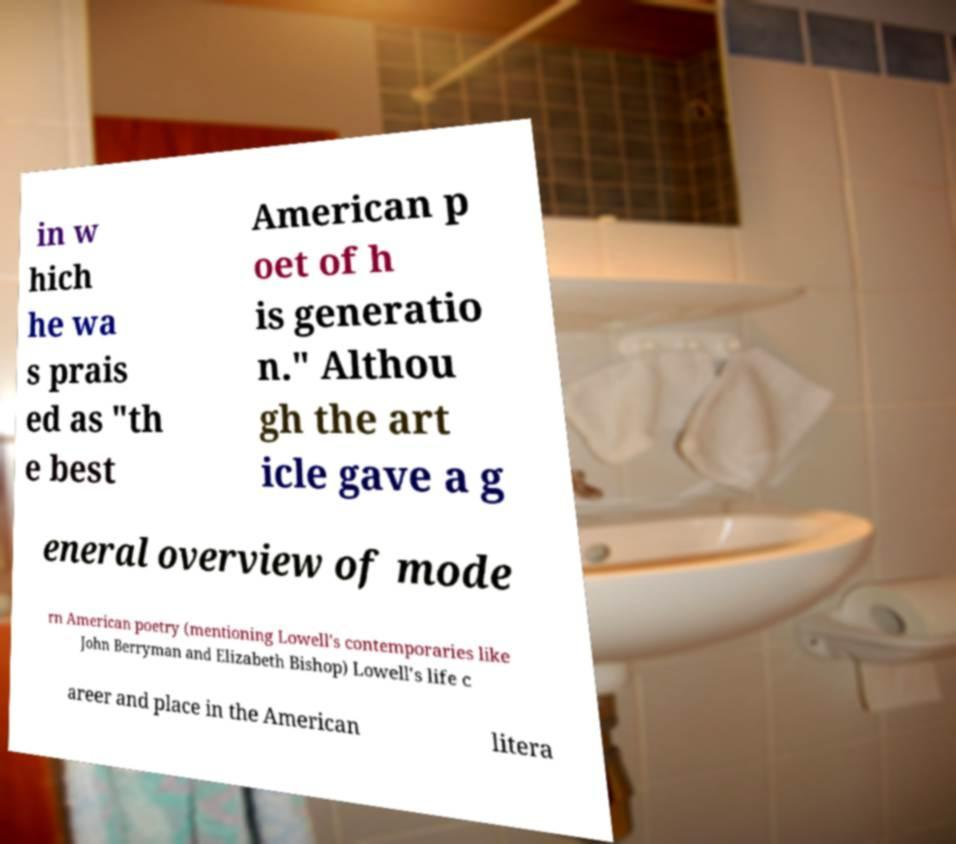Could you extract and type out the text from this image? in w hich he wa s prais ed as "th e best American p oet of h is generatio n." Althou gh the art icle gave a g eneral overview of mode rn American poetry (mentioning Lowell's contemporaries like John Berryman and Elizabeth Bishop) Lowell's life c areer and place in the American litera 